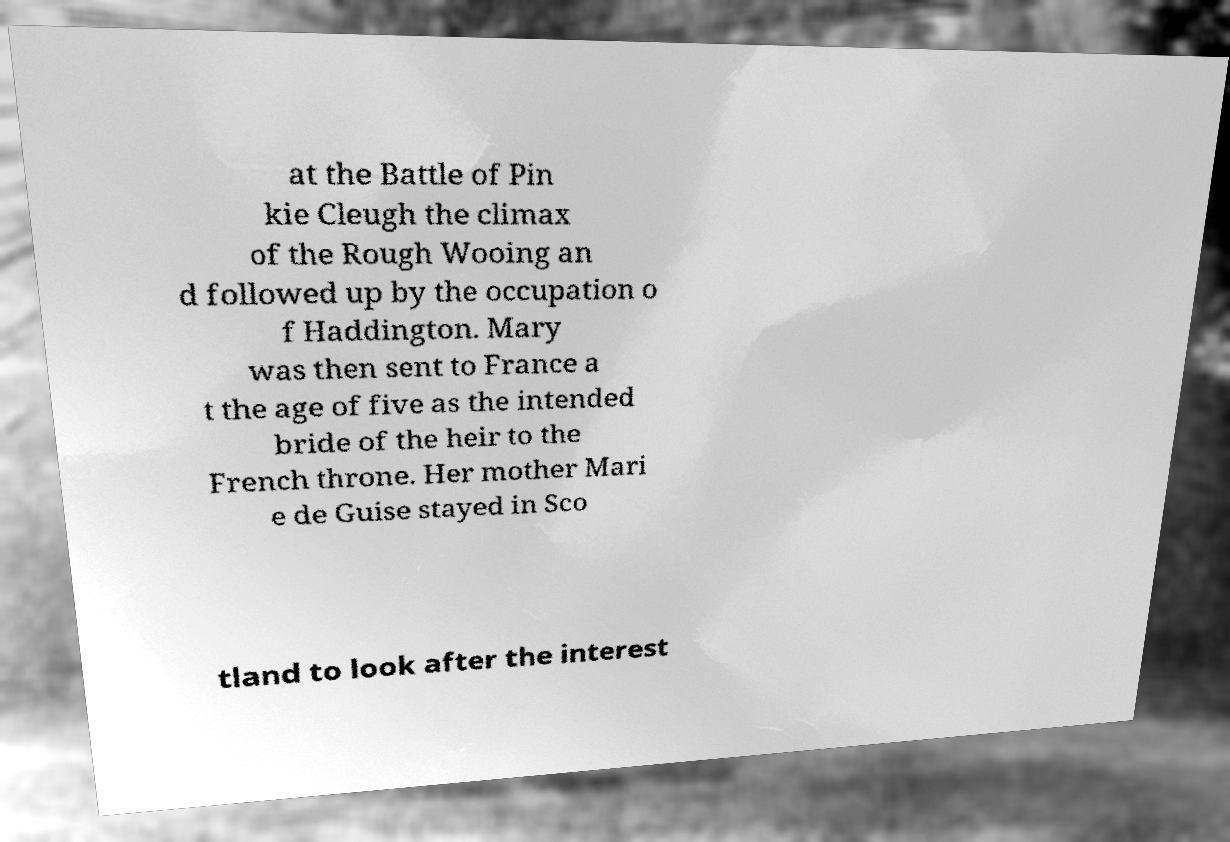Can you read and provide the text displayed in the image?This photo seems to have some interesting text. Can you extract and type it out for me? at the Battle of Pin kie Cleugh the climax of the Rough Wooing an d followed up by the occupation o f Haddington. Mary was then sent to France a t the age of five as the intended bride of the heir to the French throne. Her mother Mari e de Guise stayed in Sco tland to look after the interest 